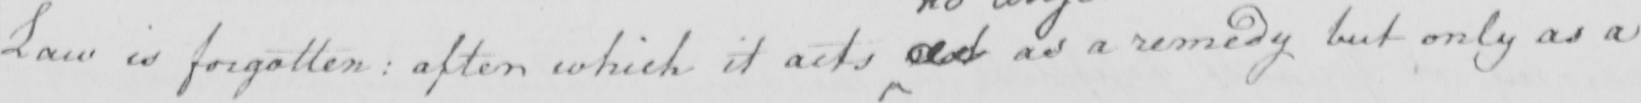Please transcribe the handwritten text in this image. Law is forgotten :  after which it acts not as a remedy but only as a 